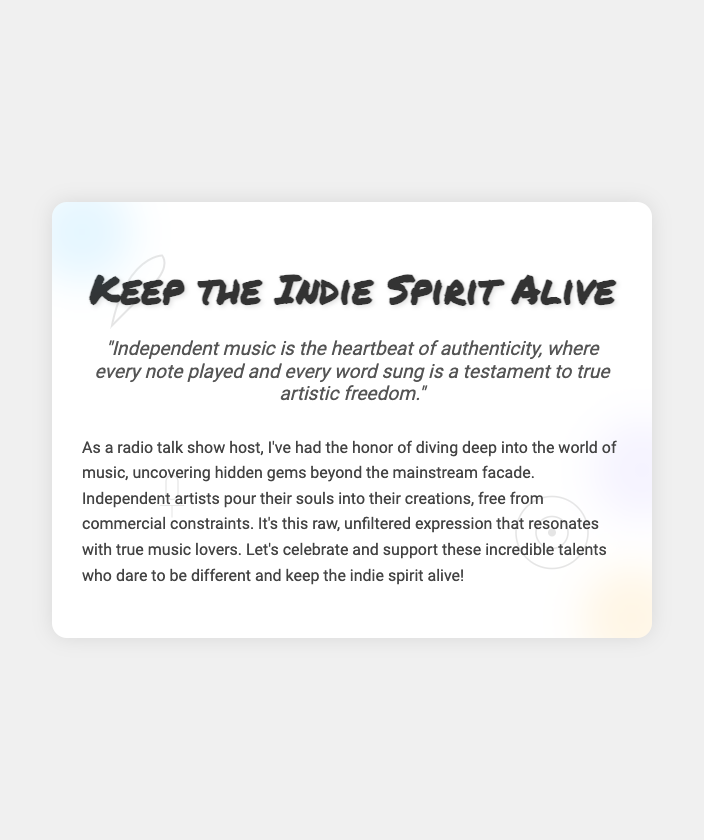What is the title of the card? The title of the card is prominently displayed at the top of the card content.
Answer: Keep the Indie Spirit Alive Who created the quote about independent music? The quote is attributed to the overall sentiment described in the message of the document, reflecting the intentions of independent artists.
Answer: Independent music What is described as the heartbeat of authenticity? The quote specifically states what serves as the heartbeat of authenticity in the music world.
Answer: Independent music What artistic elements are placed on the card? The document mentions several specific artistic elements that embellish the greeting card.
Answer: Guitar, vinyl, microphone What style is the title written in? The style of the title is defined in the CSS, indicating a specific font that contributes to its visual appeal.
Answer: Permanent Marker What does the color splash represent? The color splashes add vibrancy and artistic flair, enhancing the overall visual experience of the card.
Answer: Artistic elements How many color splashes are included in the design? The card design features a specific number of color splashes visually arranged around the content.
Answer: Three What is the main message conveyed in the card? The message elaborates on the impact and essence of independent music and its artists.
Answer: Celebrate and support independent artists What is the background color of the card? The background color, as defined in the style section, contributes to the card's overall aesthetic.
Answer: White 